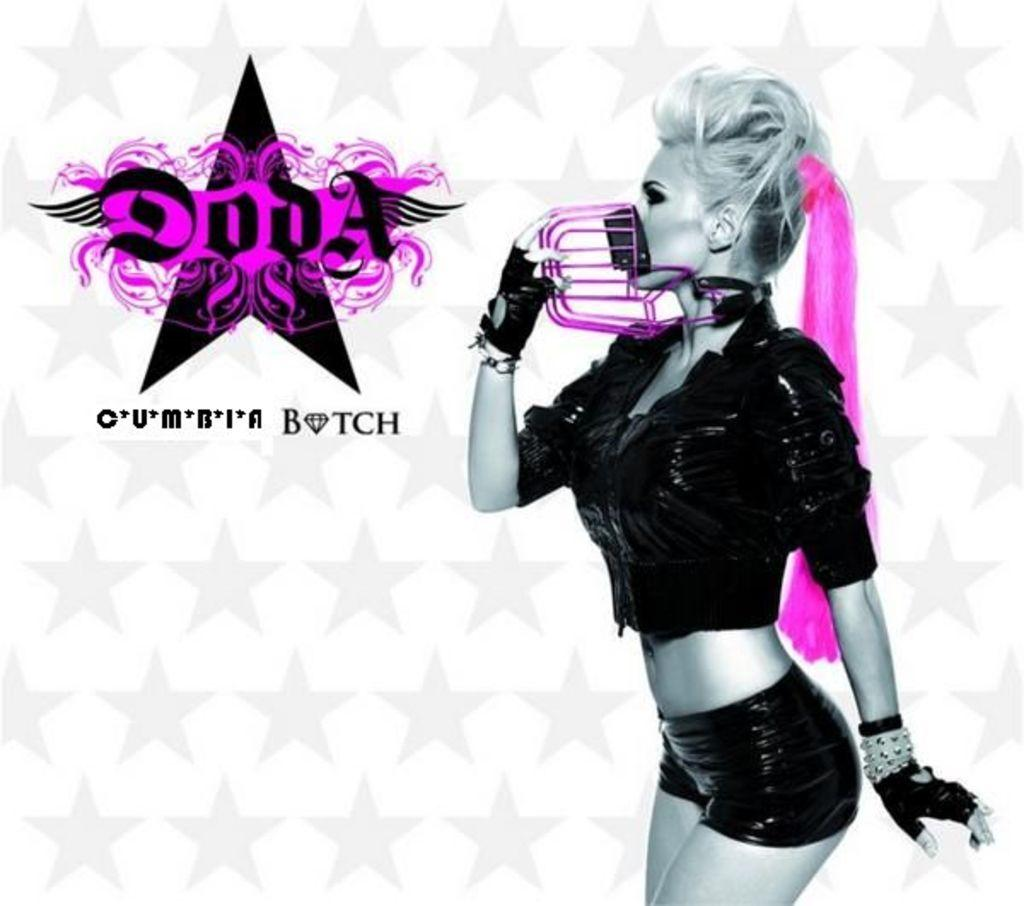What is depicted on the poster in the image? There is a poster of a woman in the image. What is the woman holding in the poster? The woman is holding an object in the poster. What else can be seen on the poster besides the woman and the object? There is text written on the poster. How many babies are crawling on the floor in the image? There are no babies present in the image. Is there a butter dish on the table in the image? There is no table or butter dish mentioned in the provided facts. 